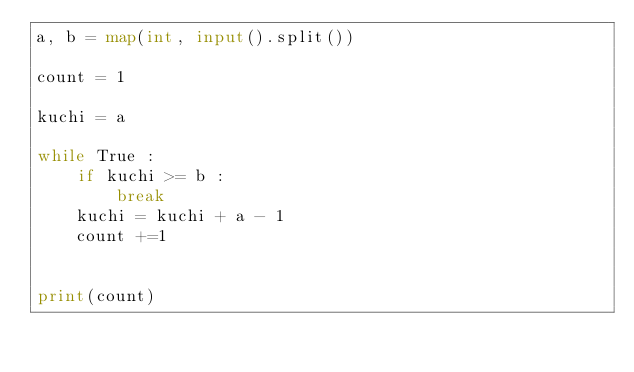Convert code to text. <code><loc_0><loc_0><loc_500><loc_500><_Python_>a, b = map(int, input().split())

count = 1

kuchi = a

while True :
    if kuchi >= b :
        break
    kuchi = kuchi + a - 1
    count +=1
    

print(count)</code> 